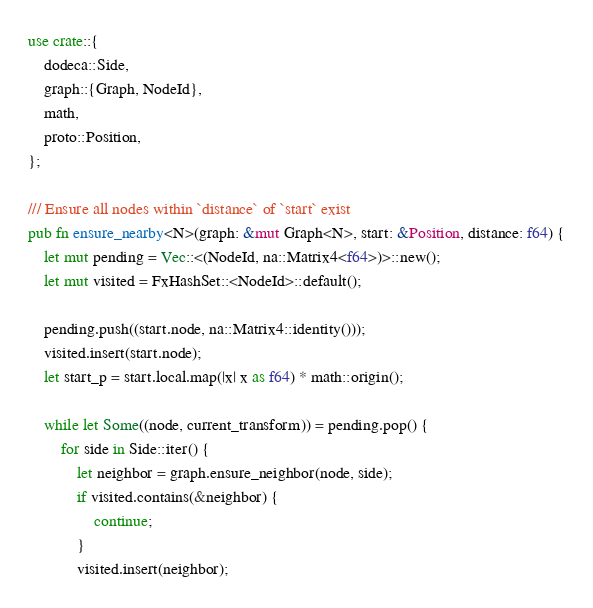<code> <loc_0><loc_0><loc_500><loc_500><_Rust_>use crate::{
    dodeca::Side,
    graph::{Graph, NodeId},
    math,
    proto::Position,
};

/// Ensure all nodes within `distance` of `start` exist
pub fn ensure_nearby<N>(graph: &mut Graph<N>, start: &Position, distance: f64) {
    let mut pending = Vec::<(NodeId, na::Matrix4<f64>)>::new();
    let mut visited = FxHashSet::<NodeId>::default();

    pending.push((start.node, na::Matrix4::identity()));
    visited.insert(start.node);
    let start_p = start.local.map(|x| x as f64) * math::origin();

    while let Some((node, current_transform)) = pending.pop() {
        for side in Side::iter() {
            let neighbor = graph.ensure_neighbor(node, side);
            if visited.contains(&neighbor) {
                continue;
            }
            visited.insert(neighbor);</code> 